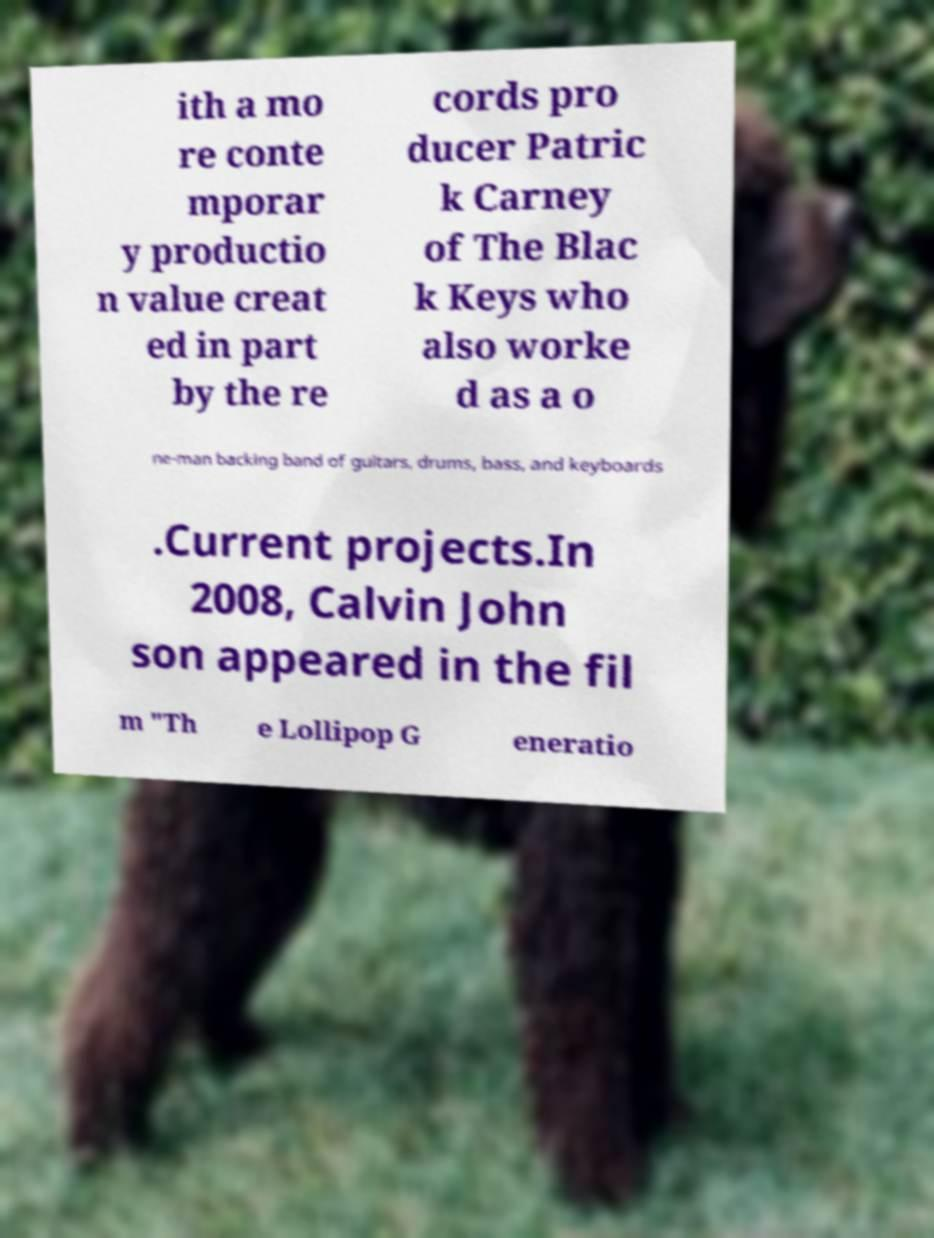For documentation purposes, I need the text within this image transcribed. Could you provide that? ith a mo re conte mporar y productio n value creat ed in part by the re cords pro ducer Patric k Carney of The Blac k Keys who also worke d as a o ne-man backing band of guitars, drums, bass, and keyboards .Current projects.In 2008, Calvin John son appeared in the fil m "Th e Lollipop G eneratio 